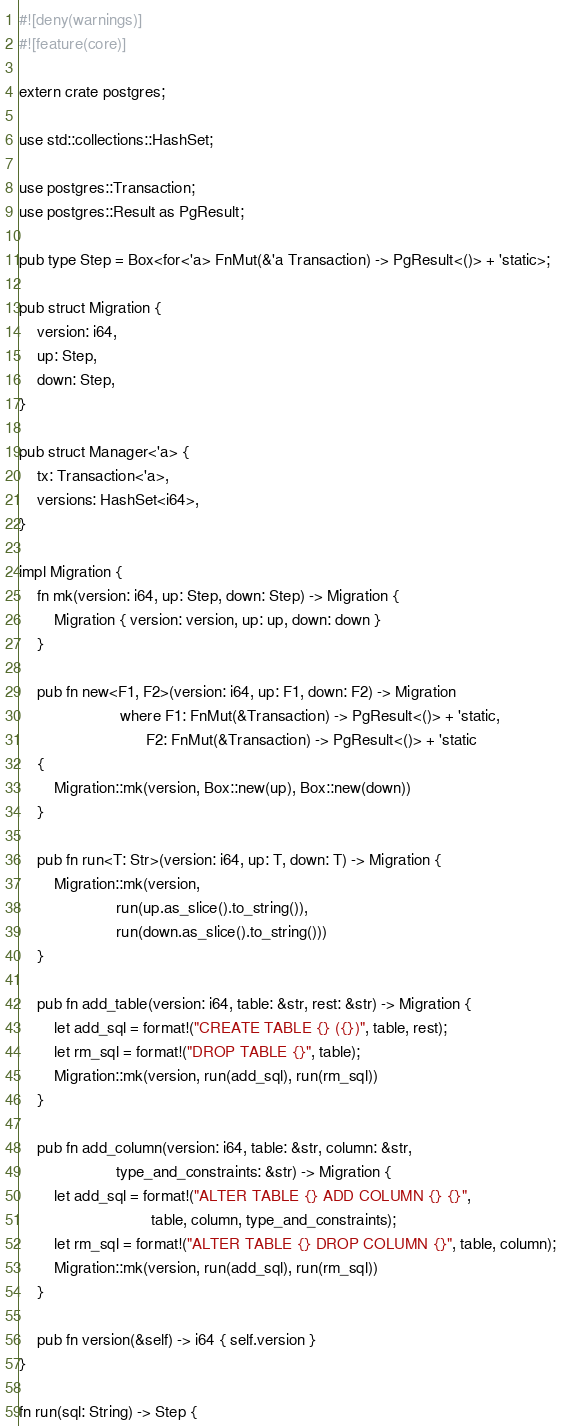<code> <loc_0><loc_0><loc_500><loc_500><_Rust_>#![deny(warnings)]
#![feature(core)]

extern crate postgres;

use std::collections::HashSet;

use postgres::Transaction;
use postgres::Result as PgResult;

pub type Step = Box<for<'a> FnMut(&'a Transaction) -> PgResult<()> + 'static>;

pub struct Migration {
    version: i64,
    up: Step,
    down: Step,
}

pub struct Manager<'a> {
    tx: Transaction<'a>,
    versions: HashSet<i64>,
}

impl Migration {
    fn mk(version: i64, up: Step, down: Step) -> Migration {
        Migration { version: version, up: up, down: down }
    }

    pub fn new<F1, F2>(version: i64, up: F1, down: F2) -> Migration
                       where F1: FnMut(&Transaction) -> PgResult<()> + 'static,
                             F2: FnMut(&Transaction) -> PgResult<()> + 'static
    {
        Migration::mk(version, Box::new(up), Box::new(down))
    }

    pub fn run<T: Str>(version: i64, up: T, down: T) -> Migration {
        Migration::mk(version,
                      run(up.as_slice().to_string()),
                      run(down.as_slice().to_string()))
    }

    pub fn add_table(version: i64, table: &str, rest: &str) -> Migration {
        let add_sql = format!("CREATE TABLE {} ({})", table, rest);
        let rm_sql = format!("DROP TABLE {}", table);
        Migration::mk(version, run(add_sql), run(rm_sql))
    }

    pub fn add_column(version: i64, table: &str, column: &str,
                      type_and_constraints: &str) -> Migration {
        let add_sql = format!("ALTER TABLE {} ADD COLUMN {} {}",
                              table, column, type_and_constraints);
        let rm_sql = format!("ALTER TABLE {} DROP COLUMN {}", table, column);
        Migration::mk(version, run(add_sql), run(rm_sql))
    }

    pub fn version(&self) -> i64 { self.version }
}

fn run(sql: String) -> Step {</code> 